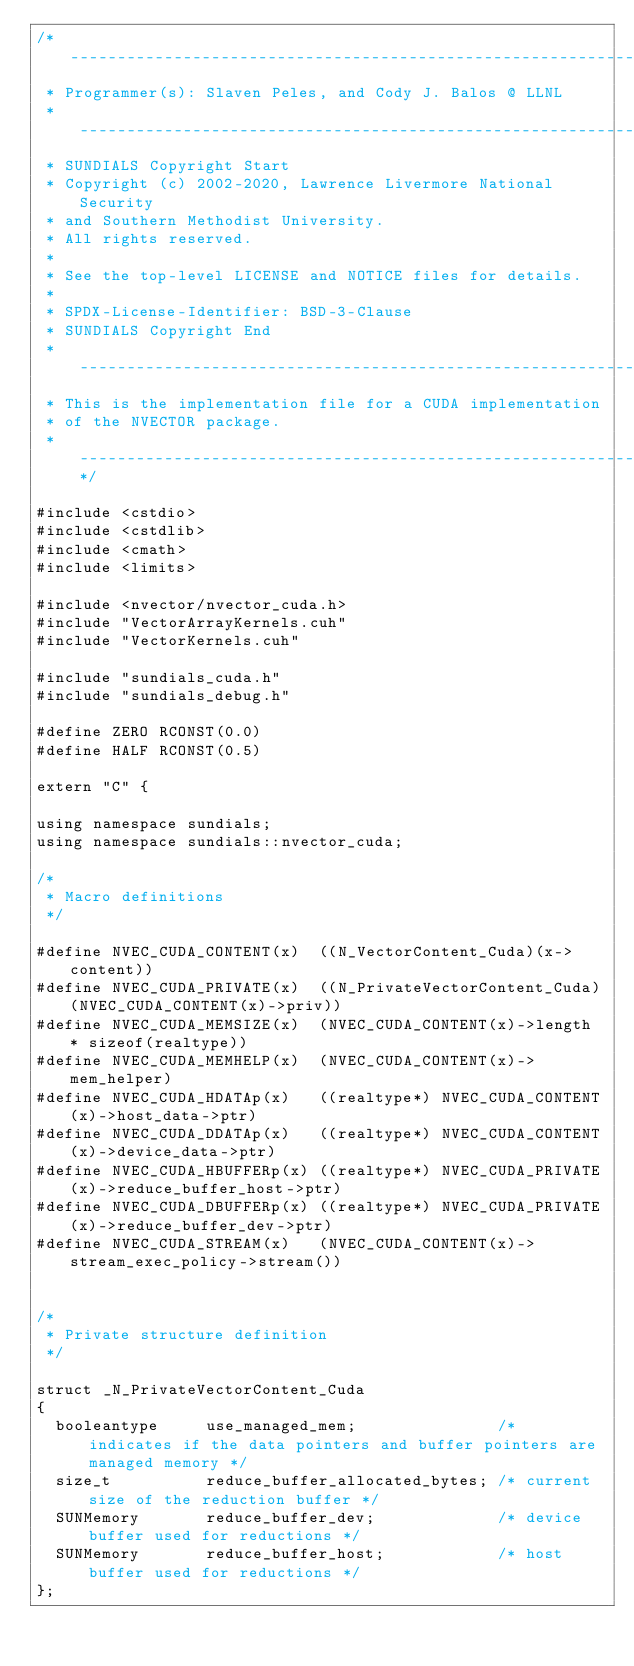Convert code to text. <code><loc_0><loc_0><loc_500><loc_500><_Cuda_>/* -----------------------------------------------------------------
 * Programmer(s): Slaven Peles, and Cody J. Balos @ LLNL
 * -----------------------------------------------------------------
 * SUNDIALS Copyright Start
 * Copyright (c) 2002-2020, Lawrence Livermore National Security
 * and Southern Methodist University.
 * All rights reserved.
 *
 * See the top-level LICENSE and NOTICE files for details.
 *
 * SPDX-License-Identifier: BSD-3-Clause
 * SUNDIALS Copyright End
 * -----------------------------------------------------------------
 * This is the implementation file for a CUDA implementation
 * of the NVECTOR package.
 * -----------------------------------------------------------------*/

#include <cstdio>
#include <cstdlib>
#include <cmath>
#include <limits>

#include <nvector/nvector_cuda.h>
#include "VectorArrayKernels.cuh"
#include "VectorKernels.cuh"

#include "sundials_cuda.h"
#include "sundials_debug.h"

#define ZERO RCONST(0.0)
#define HALF RCONST(0.5)

extern "C" {

using namespace sundials;
using namespace sundials::nvector_cuda;

/*
 * Macro definitions
 */

#define NVEC_CUDA_CONTENT(x)  ((N_VectorContent_Cuda)(x->content))
#define NVEC_CUDA_PRIVATE(x)  ((N_PrivateVectorContent_Cuda)(NVEC_CUDA_CONTENT(x)->priv))
#define NVEC_CUDA_MEMSIZE(x)  (NVEC_CUDA_CONTENT(x)->length * sizeof(realtype))
#define NVEC_CUDA_MEMHELP(x)  (NVEC_CUDA_CONTENT(x)->mem_helper)
#define NVEC_CUDA_HDATAp(x)   ((realtype*) NVEC_CUDA_CONTENT(x)->host_data->ptr)
#define NVEC_CUDA_DDATAp(x)   ((realtype*) NVEC_CUDA_CONTENT(x)->device_data->ptr)
#define NVEC_CUDA_HBUFFERp(x) ((realtype*) NVEC_CUDA_PRIVATE(x)->reduce_buffer_host->ptr)
#define NVEC_CUDA_DBUFFERp(x) ((realtype*) NVEC_CUDA_PRIVATE(x)->reduce_buffer_dev->ptr)
#define NVEC_CUDA_STREAM(x)   (NVEC_CUDA_CONTENT(x)->stream_exec_policy->stream())


/*
 * Private structure definition
 */

struct _N_PrivateVectorContent_Cuda
{
  booleantype     use_managed_mem;               /* indicates if the data pointers and buffer pointers are managed memory */
  size_t          reduce_buffer_allocated_bytes; /* current size of the reduction buffer */
  SUNMemory       reduce_buffer_dev;             /* device buffer used for reductions */
  SUNMemory       reduce_buffer_host;            /* host buffer used for reductions */
};
</code> 